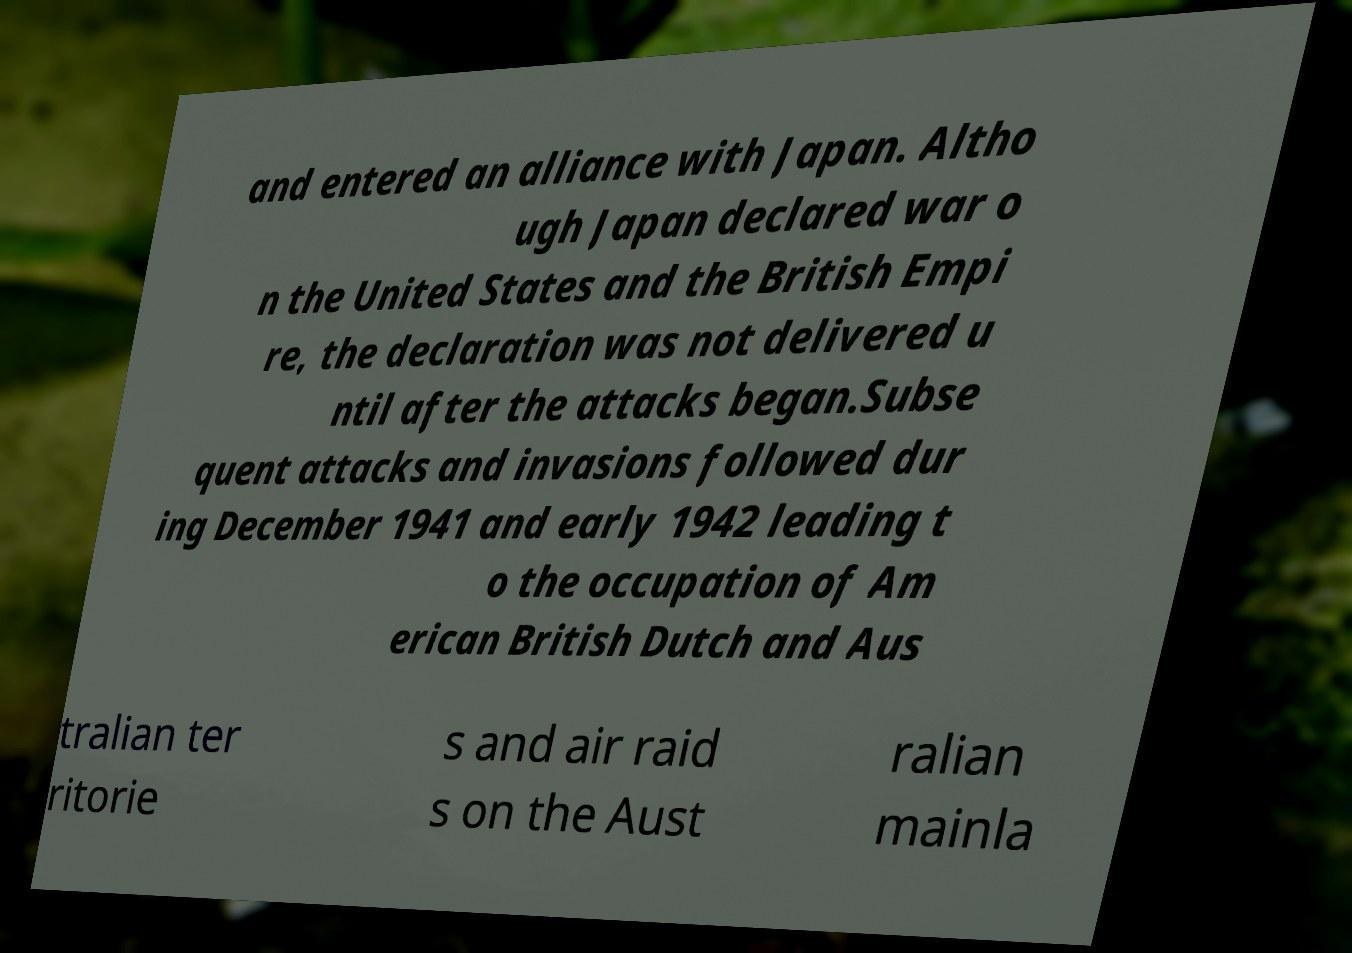Please read and relay the text visible in this image. What does it say? and entered an alliance with Japan. Altho ugh Japan declared war o n the United States and the British Empi re, the declaration was not delivered u ntil after the attacks began.Subse quent attacks and invasions followed dur ing December 1941 and early 1942 leading t o the occupation of Am erican British Dutch and Aus tralian ter ritorie s and air raid s on the Aust ralian mainla 